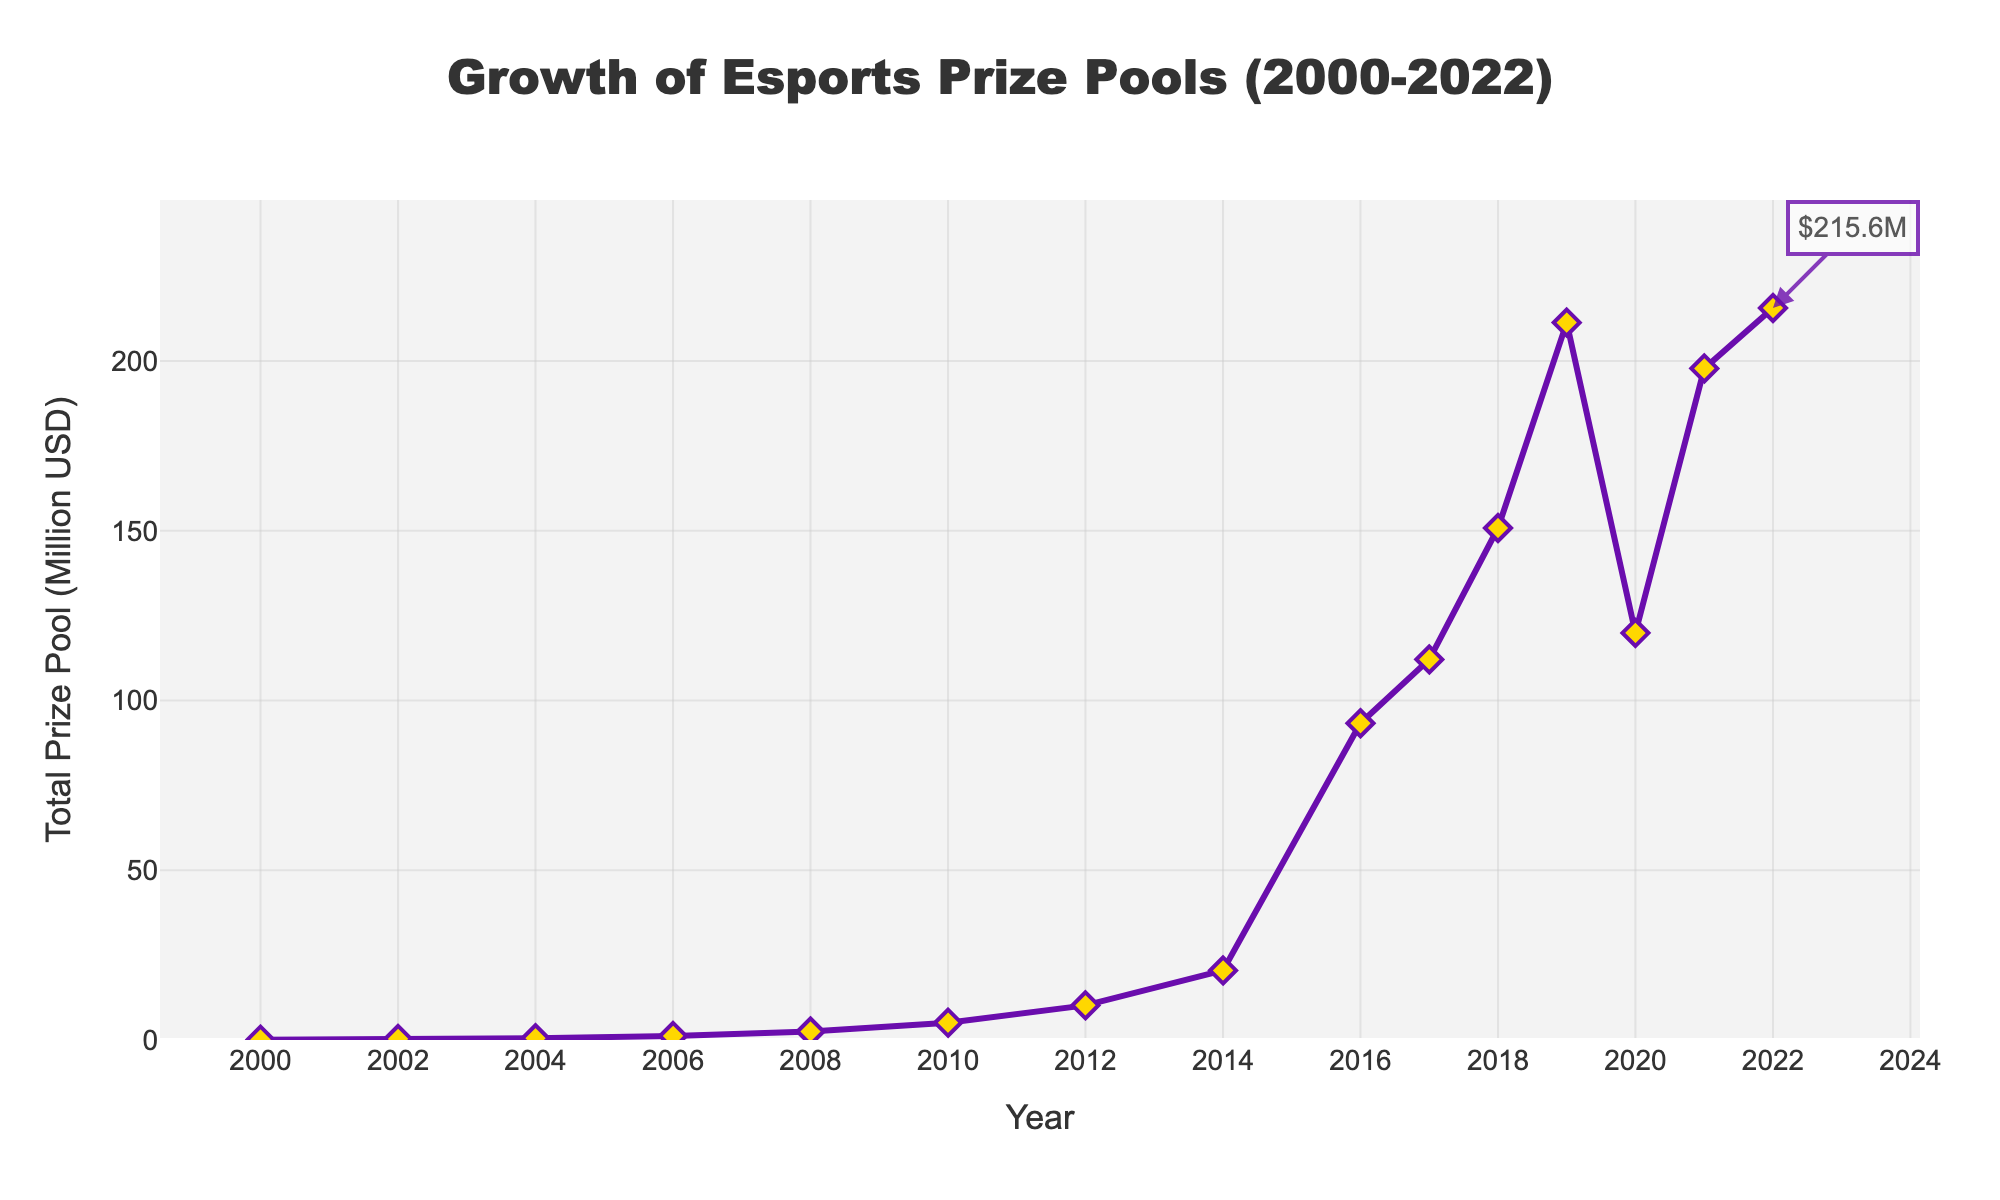What was the total prize pool in 2010? Look at the data point corresponding to the year 2010 on the x-axis and find the y-axis value.
Answer: 5.1 million USD In which year did the total prize pool first exceed 100 million USD? Check the year on the x-axis where the prize pool y-axis value surpassed 100 million USD for the first time.
Answer: 2016 What was the increase in total prize pool from 2010 to 2014? Identify the prize pool values for 2010 and 2014 from the y-axis and subtract the 2010 value from the 2014 value (20.5 - 5.1).
Answer: 15.4 million USD Which year saw the largest drop in the total prize pool? Compare the decrease in prize pool values year-over-year and find the largest drop, which occurred between 2019 and 2020 (211.3 - 119.9).
Answer: 2020 How much did the total prize pool grow from 2000 to 2022? Subtract the prize pool value in 2000 from the value in 2022 (215.6 - 0.1).
Answer: 215.5 million USD What is the average total prize pool value from 2016 to 2022? Sum the prize pool values from 2016 to 2022 and divide by the number of years (93.3 + 112.1 + 150.8 + 211.3 + 119.9 + 197.8 + 215.6) / 7.
Answer: 157.2 million USD What was the percentage increase in the total prize pool between 2006 and 2008? Calculate the increase (2.5 - 1.2), divide by the 2006 value (1.2), and multiply by 100 ((2.5 - 1.2) / 1.2 * 100).
Answer: 108.3% Do the total prize pool values between 2008 and 2014 form a smooth upward trend or are there fluctuations? Examine the values for 2008, 2010, 2012, and 2014, and note that each year shows a sequential increase.
Answer: Smooth upward trend Which year had a higher total prize pool, 2018 or 2021? Compare the prize pool values for 2018 and 2021 and see which is greater (150.8 vs 197.8).
Answer: 2021 What can you infer about the trend of the total prize pool from 2019 to 2022? Analyze the prize pool values over these years to identify the pattern: a drop in 2020 followed by an increase in 2021 and 2022.
Answer: Decreasing in 2020, increasing in 2021 and 2022 